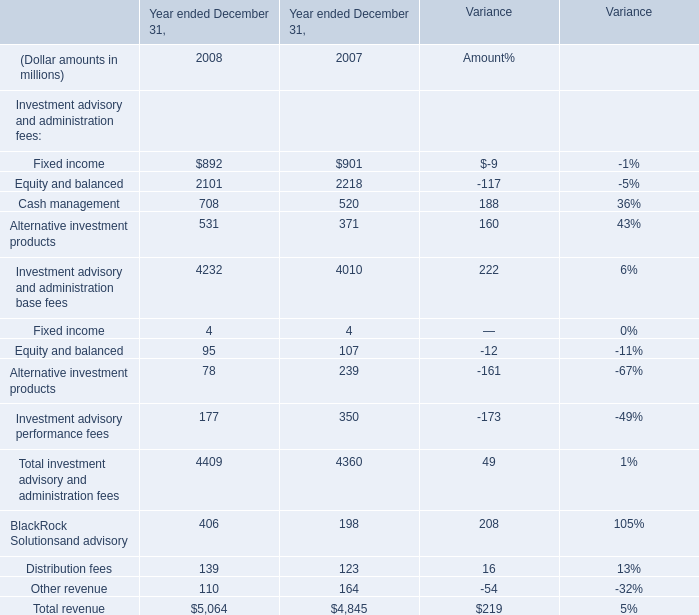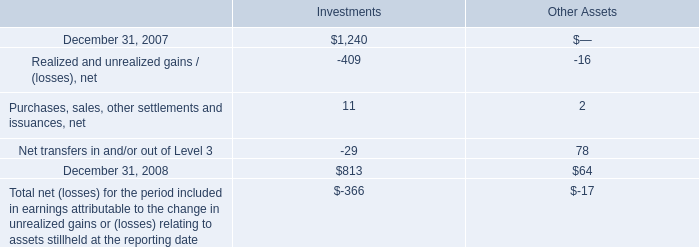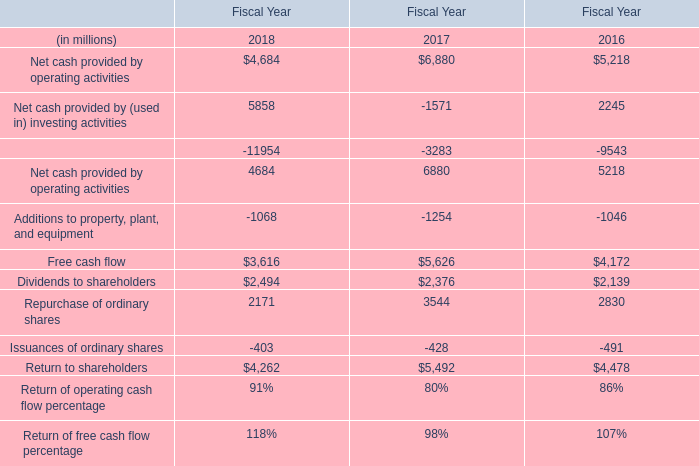What's the total amount of Cash management and Alternative investment productsin 2008? (in millions) 
Computations: (708 + 531)
Answer: 1239.0. 